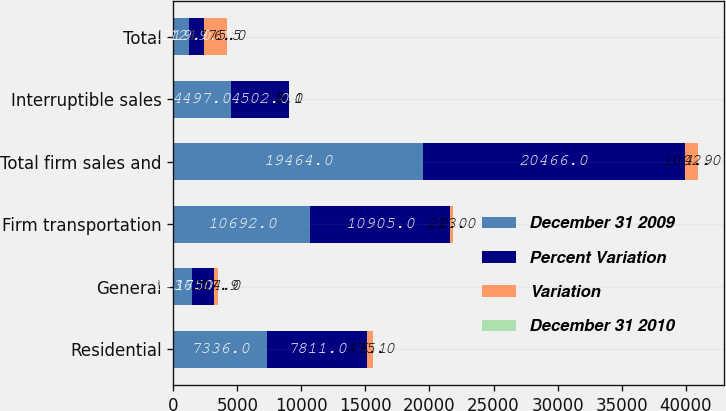<chart> <loc_0><loc_0><loc_500><loc_500><stacked_bar_chart><ecel><fcel>Residential<fcel>General<fcel>Firm transportation<fcel>Total firm sales and<fcel>Interruptible sales<fcel>Total<nl><fcel>December 31 2009<fcel>7336<fcel>1436<fcel>10692<fcel>19464<fcel>4497<fcel>1219<nl><fcel>Percent Variation<fcel>7811<fcel>1750<fcel>10905<fcel>20466<fcel>4502<fcel>1219<nl><fcel>Variation<fcel>475<fcel>314<fcel>213<fcel>1002<fcel>5<fcel>1775<nl><fcel>December 31 2010<fcel>6.1<fcel>17.9<fcel>2<fcel>4.9<fcel>0.1<fcel>6.5<nl></chart> 